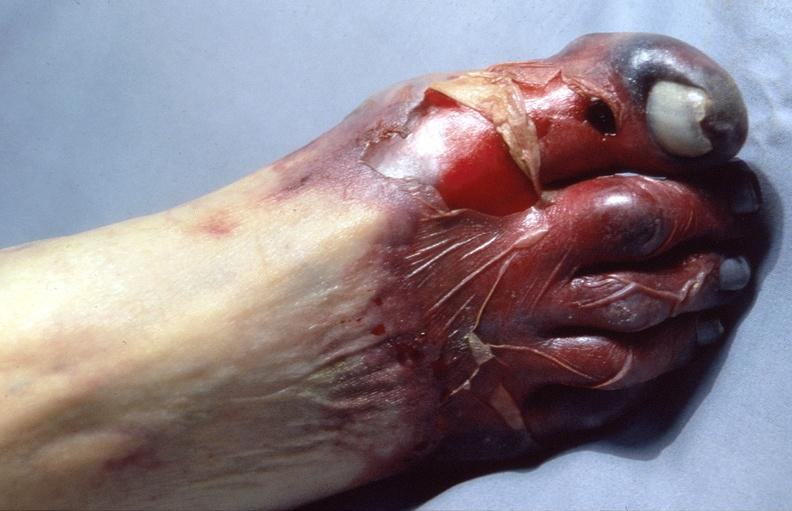does right leaf of diaphragm show skin ulceration and necrosis, disseminated intravascular coagulation due to acetaminophen toxicity?
Answer the question using a single word or phrase. No 